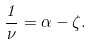Convert formula to latex. <formula><loc_0><loc_0><loc_500><loc_500>\frac { 1 } { \nu } = \alpha - \zeta .</formula> 